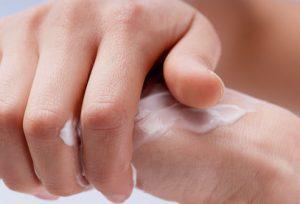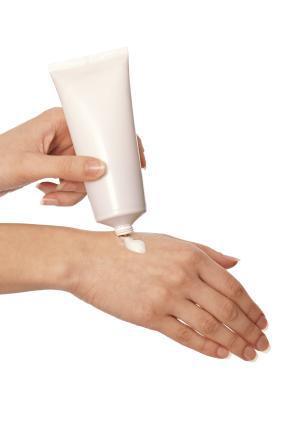The first image is the image on the left, the second image is the image on the right. Given the left and right images, does the statement "In one of the images, one hand has a glob of white lotion in the palm." hold true? Answer yes or no. No. The first image is the image on the left, the second image is the image on the right. Given the left and right images, does the statement "The left and right image contains a total of four hands with lotion being rubbed on the back of one hand." hold true? Answer yes or no. Yes. 